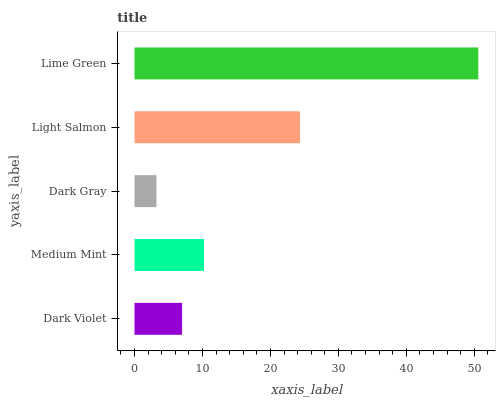Is Dark Gray the minimum?
Answer yes or no. Yes. Is Lime Green the maximum?
Answer yes or no. Yes. Is Medium Mint the minimum?
Answer yes or no. No. Is Medium Mint the maximum?
Answer yes or no. No. Is Medium Mint greater than Dark Violet?
Answer yes or no. Yes. Is Dark Violet less than Medium Mint?
Answer yes or no. Yes. Is Dark Violet greater than Medium Mint?
Answer yes or no. No. Is Medium Mint less than Dark Violet?
Answer yes or no. No. Is Medium Mint the high median?
Answer yes or no. Yes. Is Medium Mint the low median?
Answer yes or no. Yes. Is Light Salmon the high median?
Answer yes or no. No. Is Dark Gray the low median?
Answer yes or no. No. 